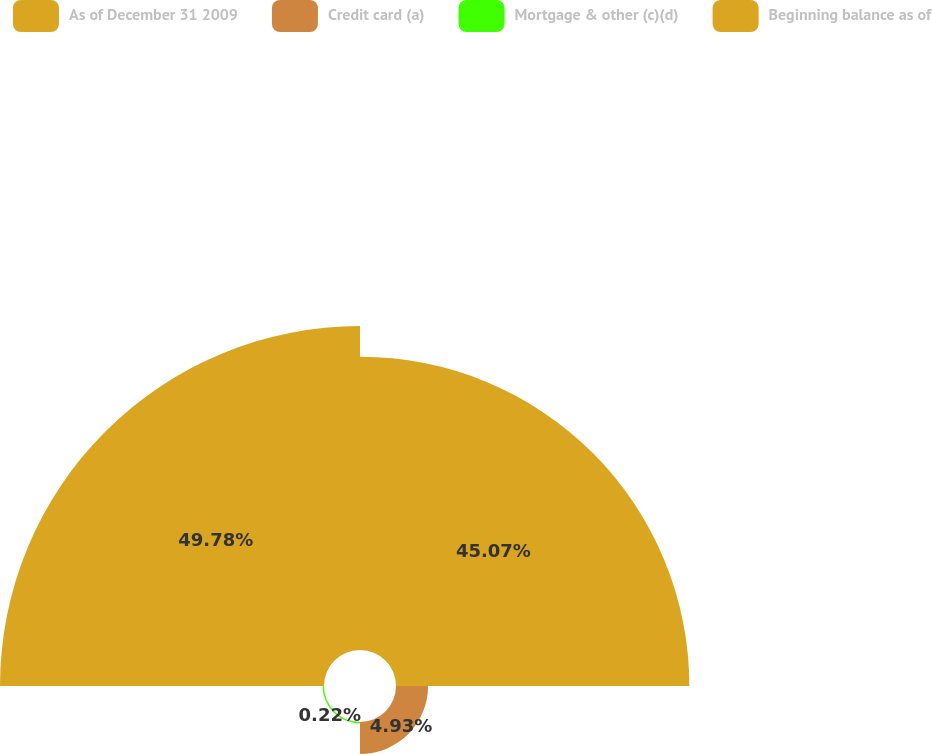<chart> <loc_0><loc_0><loc_500><loc_500><pie_chart><fcel>As of December 31 2009<fcel>Credit card (a)<fcel>Mortgage & other (c)(d)<fcel>Beginning balance as of<nl><fcel>45.07%<fcel>4.93%<fcel>0.22%<fcel>49.78%<nl></chart> 